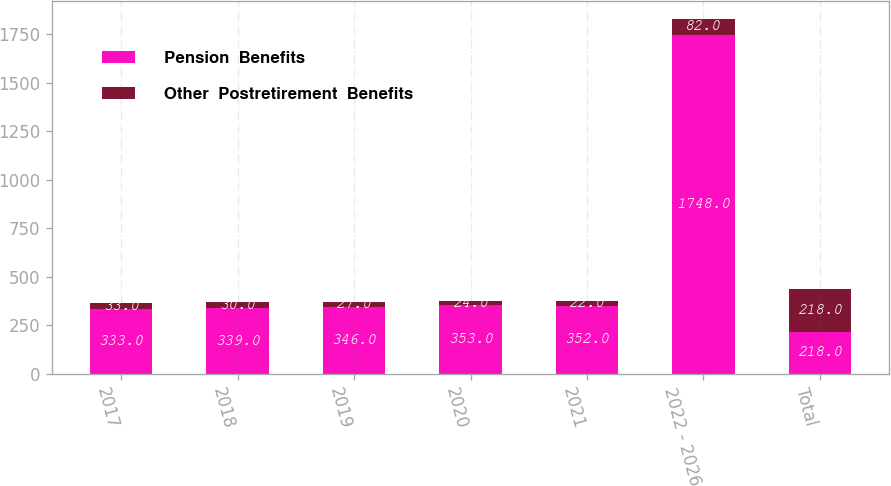Convert chart to OTSL. <chart><loc_0><loc_0><loc_500><loc_500><stacked_bar_chart><ecel><fcel>2017<fcel>2018<fcel>2019<fcel>2020<fcel>2021<fcel>2022 - 2026<fcel>Total<nl><fcel>Pension  Benefits<fcel>333<fcel>339<fcel>346<fcel>353<fcel>352<fcel>1748<fcel>218<nl><fcel>Other  Postretirement  Benefits<fcel>33<fcel>30<fcel>27<fcel>24<fcel>22<fcel>82<fcel>218<nl></chart> 